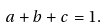<formula> <loc_0><loc_0><loc_500><loc_500>a + b + c = 1 .</formula> 